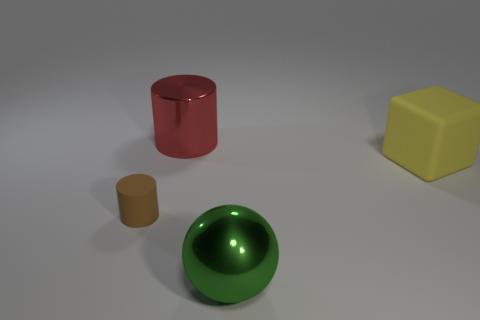Add 1 large green cubes. How many objects exist? 5 Subtract all blocks. How many objects are left? 3 Add 1 big red metal cylinders. How many big red metal cylinders exist? 2 Subtract 1 red cylinders. How many objects are left? 3 Subtract all yellow cubes. Subtract all big red metallic cylinders. How many objects are left? 2 Add 1 green things. How many green things are left? 2 